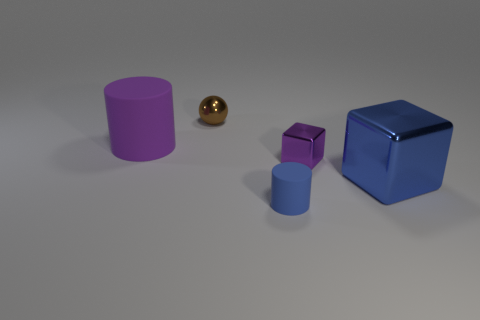What number of objects are either cylinders that are behind the tiny purple cube or purple objects that are to the left of the tiny sphere?
Your response must be concise. 1. There is a large object that is the same color as the tiny block; what is its shape?
Give a very brief answer. Cylinder. There is a small metallic thing that is in front of the large matte thing; what is its shape?
Provide a short and direct response. Cube. Does the purple thing that is to the right of the purple cylinder have the same shape as the big blue thing?
Give a very brief answer. Yes. How many things are things that are on the left side of the tiny block or tiny purple shiny balls?
Offer a terse response. 3. There is another object that is the same shape as the small blue thing; what color is it?
Your answer should be very brief. Purple. Are there any other things that have the same color as the small rubber cylinder?
Your answer should be very brief. Yes. There is a rubber thing that is to the left of the sphere; how big is it?
Your response must be concise. Large. Do the large matte cylinder and the cube that is to the left of the big block have the same color?
Keep it short and to the point. Yes. What number of other objects are there of the same material as the tiny blue cylinder?
Your answer should be very brief. 1. 